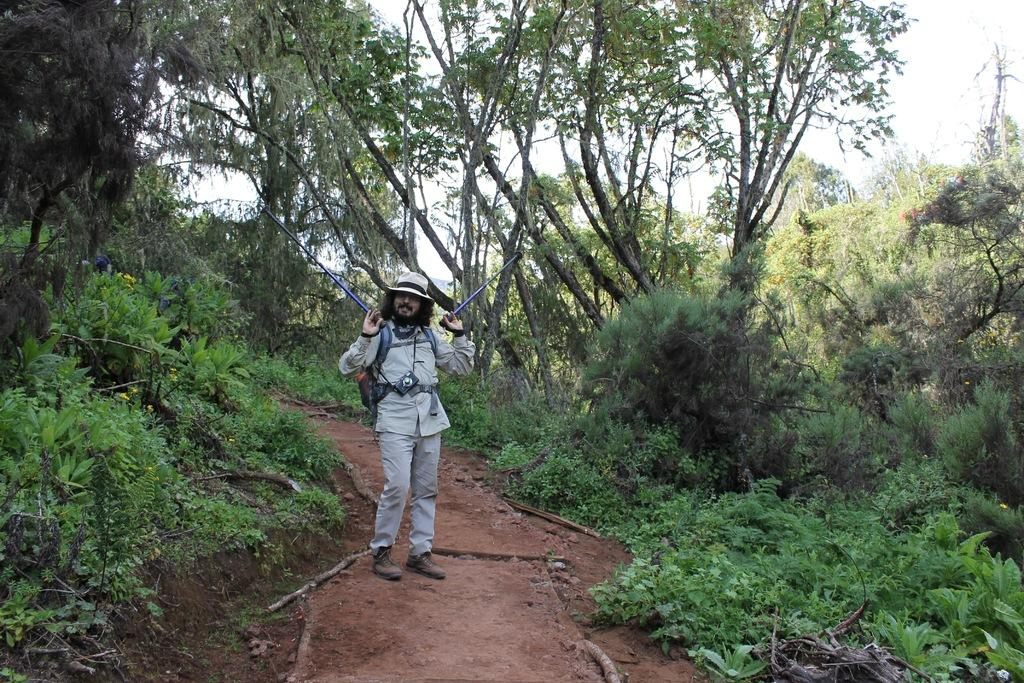Who or what is present in the image? There is a person in the image. What is the person wearing on their head? The person is wearing a hat. What is the person holding in their hands? The person is holding sticks. What can be seen in the background of the image? There are plants, trees, and the sky visible in the background of the image. What type of structure is being shown in the image? There is no structure being shown in the image; it primarily features a person and their surroundings. 